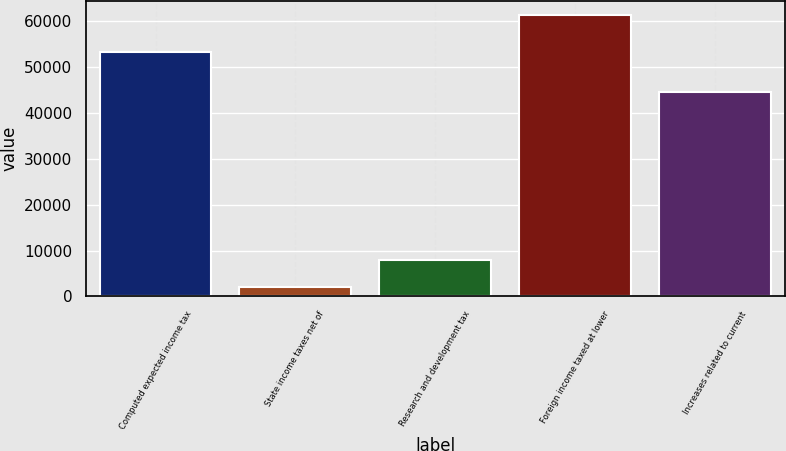<chart> <loc_0><loc_0><loc_500><loc_500><bar_chart><fcel>Computed expected income tax<fcel>State income taxes net of<fcel>Research and development tax<fcel>Foreign income taxed at lower<fcel>Increases related to current<nl><fcel>53262<fcel>2054<fcel>7986.3<fcel>61377<fcel>44661<nl></chart> 